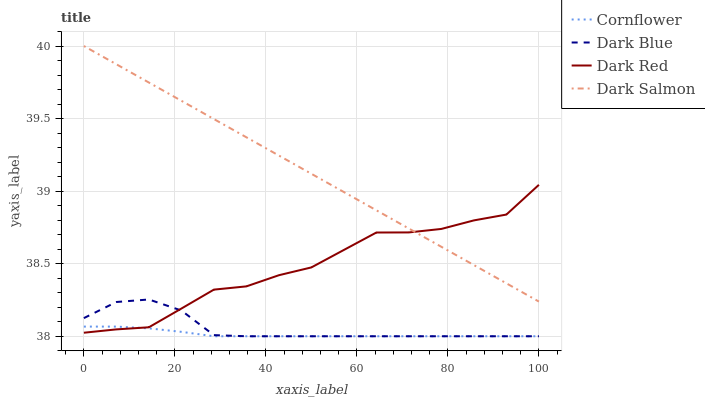Does Cornflower have the minimum area under the curve?
Answer yes or no. Yes. Does Dark Salmon have the maximum area under the curve?
Answer yes or no. Yes. Does Dark Red have the minimum area under the curve?
Answer yes or no. No. Does Dark Red have the maximum area under the curve?
Answer yes or no. No. Is Dark Salmon the smoothest?
Answer yes or no. Yes. Is Dark Red the roughest?
Answer yes or no. Yes. Is Dark Red the smoothest?
Answer yes or no. No. Is Dark Salmon the roughest?
Answer yes or no. No. Does Cornflower have the lowest value?
Answer yes or no. Yes. Does Dark Red have the lowest value?
Answer yes or no. No. Does Dark Salmon have the highest value?
Answer yes or no. Yes. Does Dark Red have the highest value?
Answer yes or no. No. Is Dark Blue less than Dark Salmon?
Answer yes or no. Yes. Is Dark Salmon greater than Dark Blue?
Answer yes or no. Yes. Does Cornflower intersect Dark Red?
Answer yes or no. Yes. Is Cornflower less than Dark Red?
Answer yes or no. No. Is Cornflower greater than Dark Red?
Answer yes or no. No. Does Dark Blue intersect Dark Salmon?
Answer yes or no. No. 